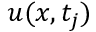Convert formula to latex. <formula><loc_0><loc_0><loc_500><loc_500>u ( x , t _ { j } )</formula> 